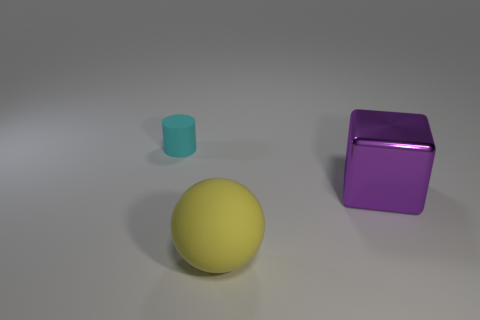There is a large object to the right of the big yellow matte thing; what shape is it?
Make the answer very short. Cube. How many metallic objects are the same size as the matte cylinder?
Offer a very short reply. 0. How big is the yellow thing?
Ensure brevity in your answer.  Large. What number of rubber cylinders are right of the cube?
Your answer should be compact. 0. There is a object that is the same material as the tiny cylinder; what is its shape?
Give a very brief answer. Sphere. Is the number of large purple cubes in front of the tiny cyan rubber cylinder less than the number of big objects that are behind the purple thing?
Offer a terse response. No. Is the number of tiny red shiny objects greater than the number of yellow balls?
Offer a very short reply. No. What is the yellow sphere made of?
Offer a terse response. Rubber. What color is the large thing that is in front of the large block?
Provide a succinct answer. Yellow. Are there more purple objects that are right of the metal cube than large shiny cubes that are on the right side of the cylinder?
Your response must be concise. No. 